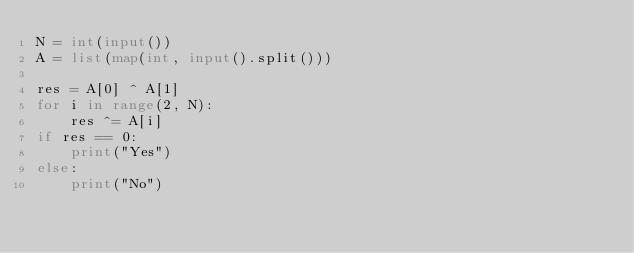Convert code to text. <code><loc_0><loc_0><loc_500><loc_500><_Python_>N = int(input())
A = list(map(int, input().split()))

res = A[0] ^ A[1]
for i in range(2, N):
    res ^= A[i]
if res == 0:
    print("Yes")
else:
    print("No")</code> 